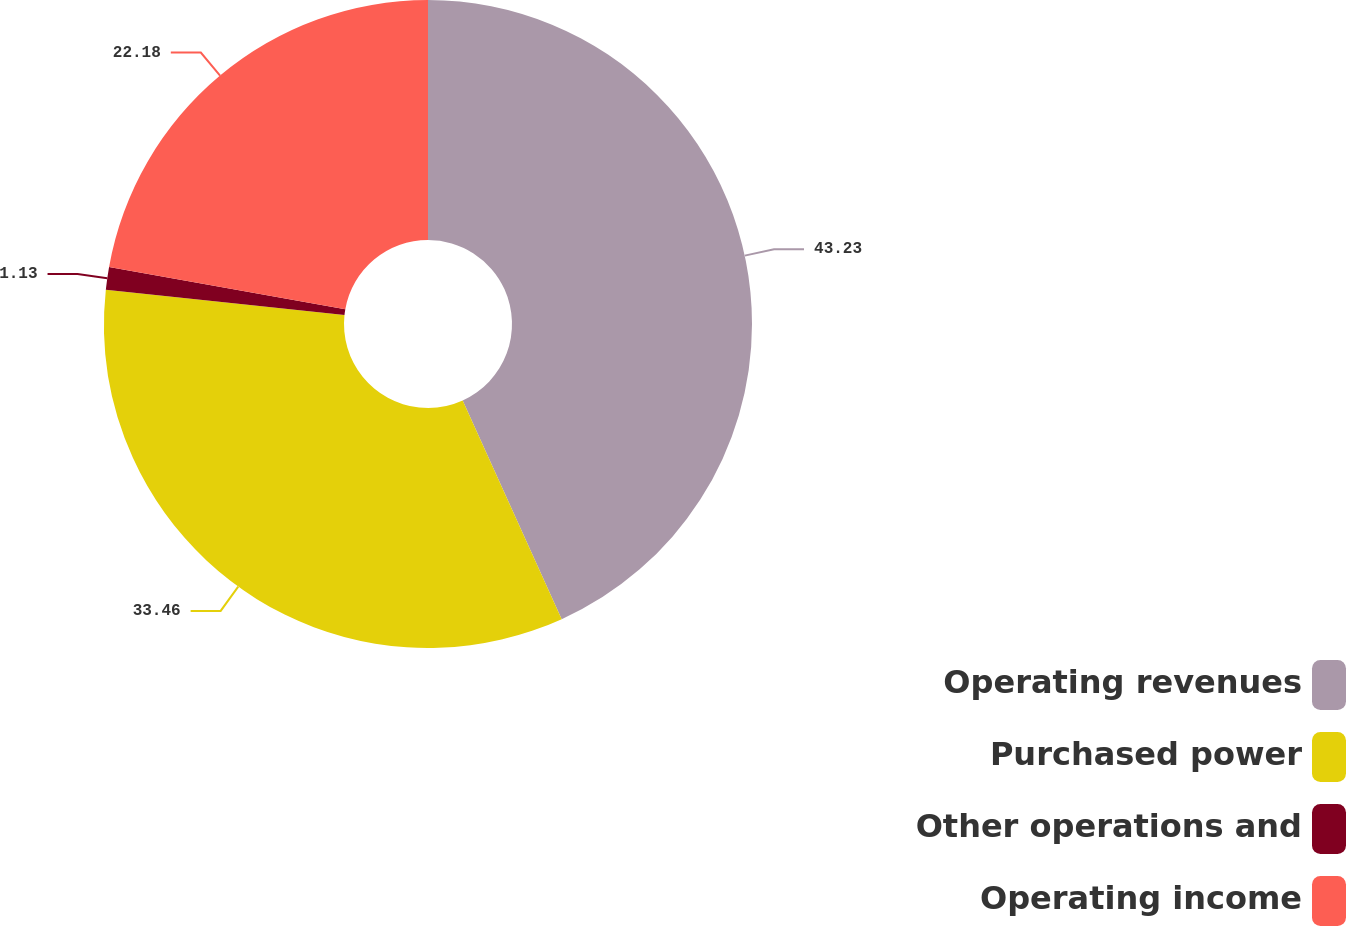Convert chart. <chart><loc_0><loc_0><loc_500><loc_500><pie_chart><fcel>Operating revenues<fcel>Purchased power<fcel>Other operations and<fcel>Operating income<nl><fcel>43.23%<fcel>33.46%<fcel>1.13%<fcel>22.18%<nl></chart> 